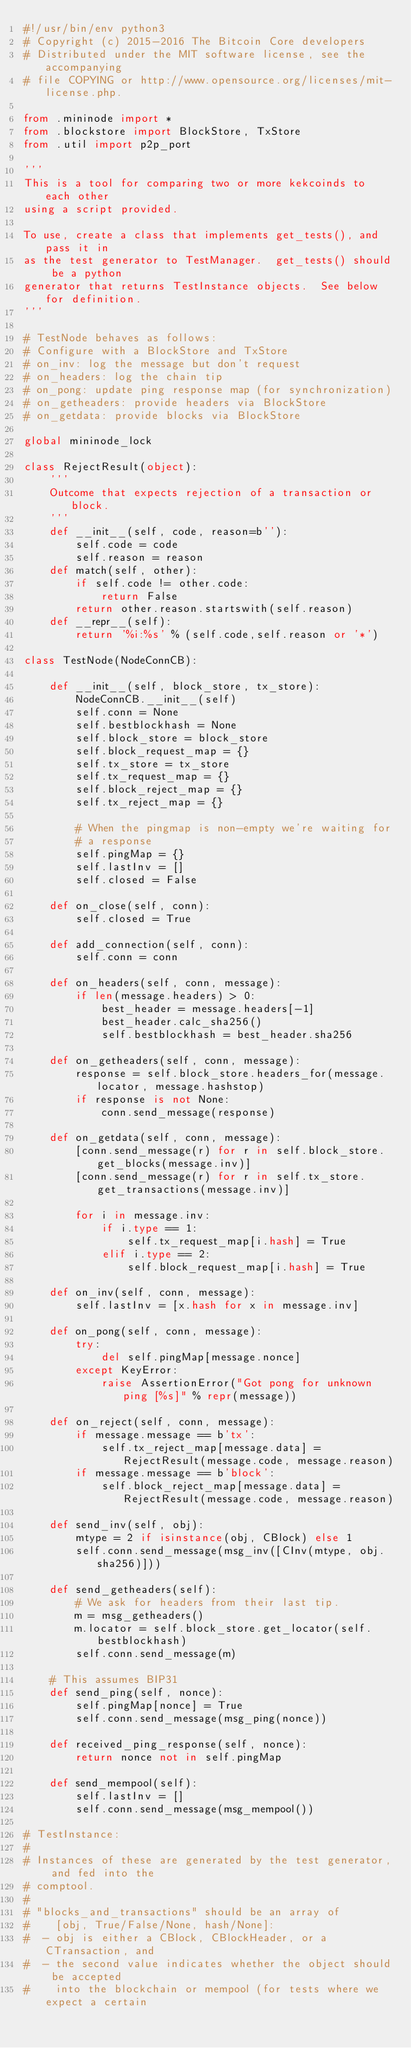Convert code to text. <code><loc_0><loc_0><loc_500><loc_500><_Python_>#!/usr/bin/env python3
# Copyright (c) 2015-2016 The Bitcoin Core developers
# Distributed under the MIT software license, see the accompanying
# file COPYING or http://www.opensource.org/licenses/mit-license.php.

from .mininode import *
from .blockstore import BlockStore, TxStore
from .util import p2p_port

'''
This is a tool for comparing two or more kekcoinds to each other
using a script provided.

To use, create a class that implements get_tests(), and pass it in
as the test generator to TestManager.  get_tests() should be a python
generator that returns TestInstance objects.  See below for definition.
'''

# TestNode behaves as follows:
# Configure with a BlockStore and TxStore
# on_inv: log the message but don't request
# on_headers: log the chain tip
# on_pong: update ping response map (for synchronization)
# on_getheaders: provide headers via BlockStore
# on_getdata: provide blocks via BlockStore

global mininode_lock

class RejectResult(object):
    '''
    Outcome that expects rejection of a transaction or block.
    '''
    def __init__(self, code, reason=b''):
        self.code = code
        self.reason = reason
    def match(self, other):
        if self.code != other.code:
            return False
        return other.reason.startswith(self.reason)
    def __repr__(self):
        return '%i:%s' % (self.code,self.reason or '*')

class TestNode(NodeConnCB):

    def __init__(self, block_store, tx_store):
        NodeConnCB.__init__(self)
        self.conn = None
        self.bestblockhash = None
        self.block_store = block_store
        self.block_request_map = {}
        self.tx_store = tx_store
        self.tx_request_map = {}
        self.block_reject_map = {}
        self.tx_reject_map = {}

        # When the pingmap is non-empty we're waiting for 
        # a response
        self.pingMap = {} 
        self.lastInv = []
        self.closed = False

    def on_close(self, conn):
        self.closed = True

    def add_connection(self, conn):
        self.conn = conn

    def on_headers(self, conn, message):
        if len(message.headers) > 0:
            best_header = message.headers[-1]
            best_header.calc_sha256()
            self.bestblockhash = best_header.sha256

    def on_getheaders(self, conn, message):
        response = self.block_store.headers_for(message.locator, message.hashstop)
        if response is not None:
            conn.send_message(response)

    def on_getdata(self, conn, message):
        [conn.send_message(r) for r in self.block_store.get_blocks(message.inv)]
        [conn.send_message(r) for r in self.tx_store.get_transactions(message.inv)]

        for i in message.inv:
            if i.type == 1:
                self.tx_request_map[i.hash] = True
            elif i.type == 2:
                self.block_request_map[i.hash] = True

    def on_inv(self, conn, message):
        self.lastInv = [x.hash for x in message.inv]

    def on_pong(self, conn, message):
        try:
            del self.pingMap[message.nonce]
        except KeyError:
            raise AssertionError("Got pong for unknown ping [%s]" % repr(message))

    def on_reject(self, conn, message):
        if message.message == b'tx':
            self.tx_reject_map[message.data] = RejectResult(message.code, message.reason)
        if message.message == b'block':
            self.block_reject_map[message.data] = RejectResult(message.code, message.reason)

    def send_inv(self, obj):
        mtype = 2 if isinstance(obj, CBlock) else 1
        self.conn.send_message(msg_inv([CInv(mtype, obj.sha256)]))

    def send_getheaders(self):
        # We ask for headers from their last tip.
        m = msg_getheaders()
        m.locator = self.block_store.get_locator(self.bestblockhash)
        self.conn.send_message(m)

    # This assumes BIP31
    def send_ping(self, nonce):
        self.pingMap[nonce] = True
        self.conn.send_message(msg_ping(nonce))

    def received_ping_response(self, nonce):
        return nonce not in self.pingMap

    def send_mempool(self):
        self.lastInv = []
        self.conn.send_message(msg_mempool())

# TestInstance:
#
# Instances of these are generated by the test generator, and fed into the
# comptool.
#
# "blocks_and_transactions" should be an array of
#    [obj, True/False/None, hash/None]:
#  - obj is either a CBlock, CBlockHeader, or a CTransaction, and
#  - the second value indicates whether the object should be accepted
#    into the blockchain or mempool (for tests where we expect a certain</code> 